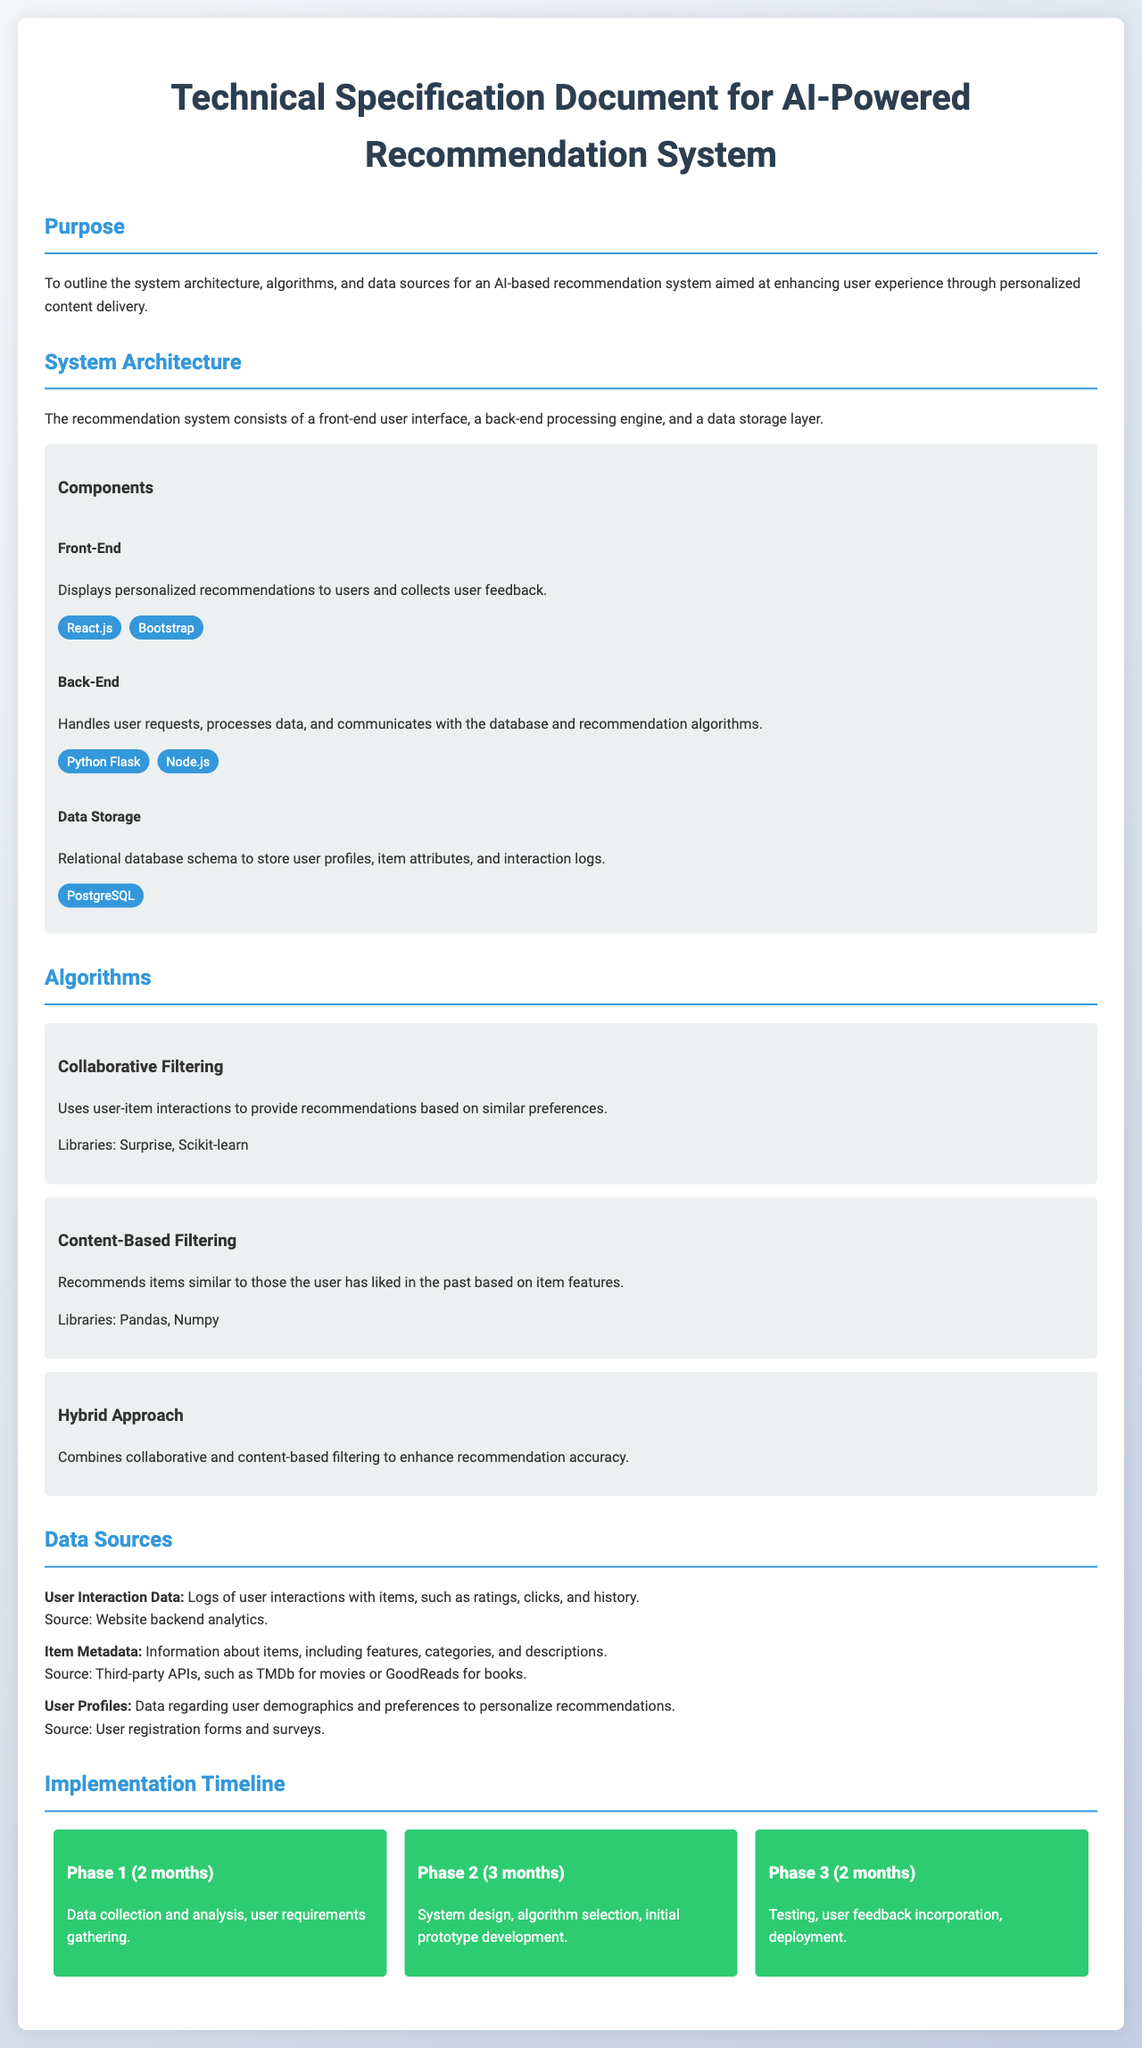What is the purpose of the document? The purpose is to outline the system architecture, algorithms, and data sources for an AI-based recommendation system aimed at enhancing user experience through personalized content delivery.
Answer: To outline the system architecture, algorithms, and data sources for an AI-based recommendation system What technology is used for the front-end? The document specifies the technologies used in each component, and for the front-end, it mentions React.js and Bootstrap.
Answer: React.js, Bootstrap Which algorithm is based on user-item interactions? The document explains the algorithms and indicates that collaborative filtering uses user-item interactions for recommendations.
Answer: Collaborative Filtering How many months are allocated for Phase 2? The implementation timeline mentions that Phase 2 will take 3 months for system design and prototype development.
Answer: 3 months Where does the user interaction data come from? The data sources section specifies that user interaction data is logged from website backend analytics.
Answer: Website backend analytics What is the main feature of the Hybrid Approach? The hybrid approach combines both collaborative and content-based filtering to improve recommendation accuracy.
Answer: Combines collaborative and content-based filtering Which database technology is used for data storage? The document lists PostgreSQL as the database technology used to store user profiles, item attributes, and interaction logs.
Answer: PostgreSQL What is the name of the library used for Content-Based Filtering? In the algorithms section, the document states that Pandas and Numpy libraries are utilized for content-based filtering.
Answer: Pandas, Numpy 